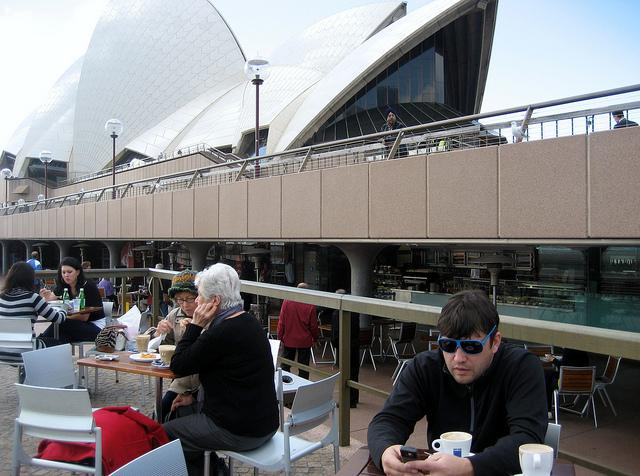What type of entertainment is commonly held in the building behind the people eating?

Choices:
A) movies
B) opera
C) standup comedy
D) hockey opera 